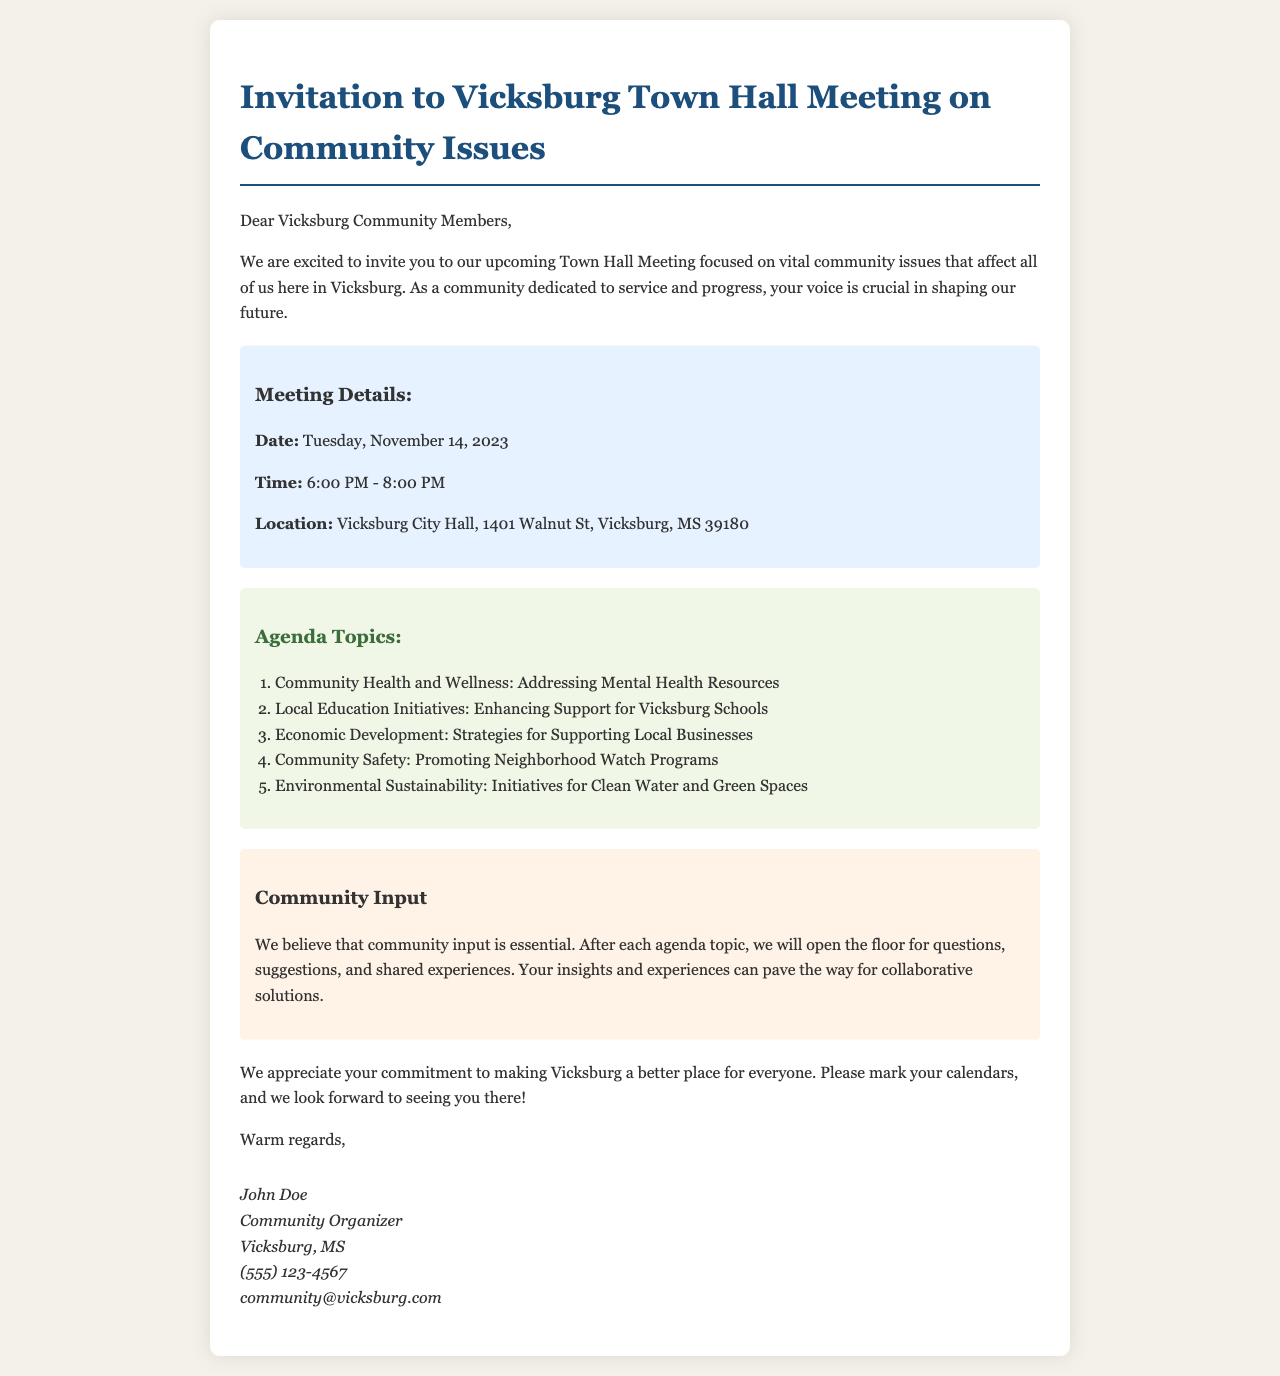What is the date of the town hall meeting? The date of the town hall meeting is explicitly stated in the document.
Answer: Tuesday, November 14, 2023 What time does the town hall meeting start? The start time is mentioned directly in the meeting details section.
Answer: 6:00 PM Where is the location of the meeting? The location is specified under the meeting details section of the document.
Answer: Vicksburg City Hall, 1401 Walnut St, Vicksburg, MS 39180 How many agenda topics are listed in the document? The number of agenda topics is found by counting the items in the list provided in the agenda section.
Answer: Five What is one of the agenda topics related to education? The agenda topics include specific subjects; one of them pertains to education.
Answer: Local Education Initiatives: Enhancing Support for Vicksburg Schools What aspect of community safety is mentioned in the agenda? The document lists specific items under the community safety topic for discussion.
Answer: Promoting Neighborhood Watch Programs Is there an opportunity for community input during the meeting? The document explicitly states the inclusion of community input.
Answer: Yes Who organized the town hall meeting? The organizer's name and title are provided at the end of the email.
Answer: John Doe What is the contact email mentioned in the document? The email address for inquiries is provided in the signature section.
Answer: community@vicksburg.com 